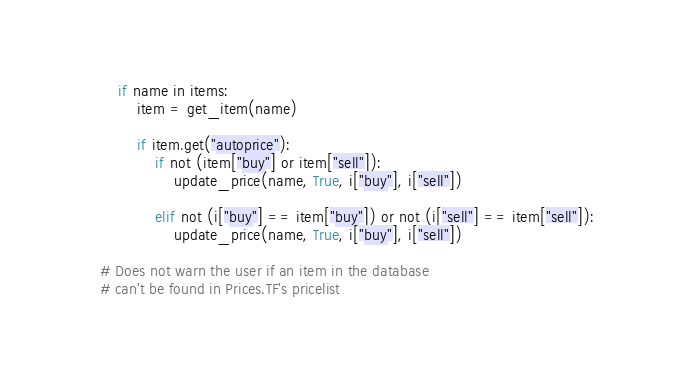Convert code to text. <code><loc_0><loc_0><loc_500><loc_500><_Python_>        if name in items:
            item = get_item(name)

            if item.get("autoprice"):
                if not (item["buy"] or item["sell"]):
                    update_price(name, True, i["buy"], i["sell"])

                elif not (i["buy"] == item["buy"]) or not (i["sell"] == item["sell"]):
                    update_price(name, True, i["buy"], i["sell"])

    # Does not warn the user if an item in the database
    # can't be found in Prices.TF's pricelist
</code> 